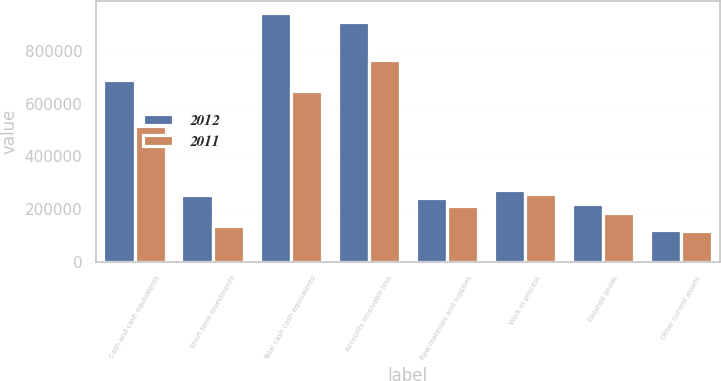Convert chart to OTSL. <chart><loc_0><loc_0><loc_500><loc_500><stacked_bar_chart><ecel><fcel>Cash and cash equivalents<fcel>Short-term investments<fcel>Total cash cash equivalents<fcel>Accounts receivable less<fcel>Raw materials and supplies<fcel>Work in process<fcel>Finished goods<fcel>Other current assets<nl><fcel>2012<fcel>690850<fcel>251653<fcel>942503<fcel>910711<fcel>243127<fcel>271669<fcel>218922<fcel>119983<nl><fcel>2011<fcel>515086<fcel>133848<fcel>648934<fcel>767181<fcel>210886<fcel>255581<fcel>183395<fcel>115260<nl></chart> 